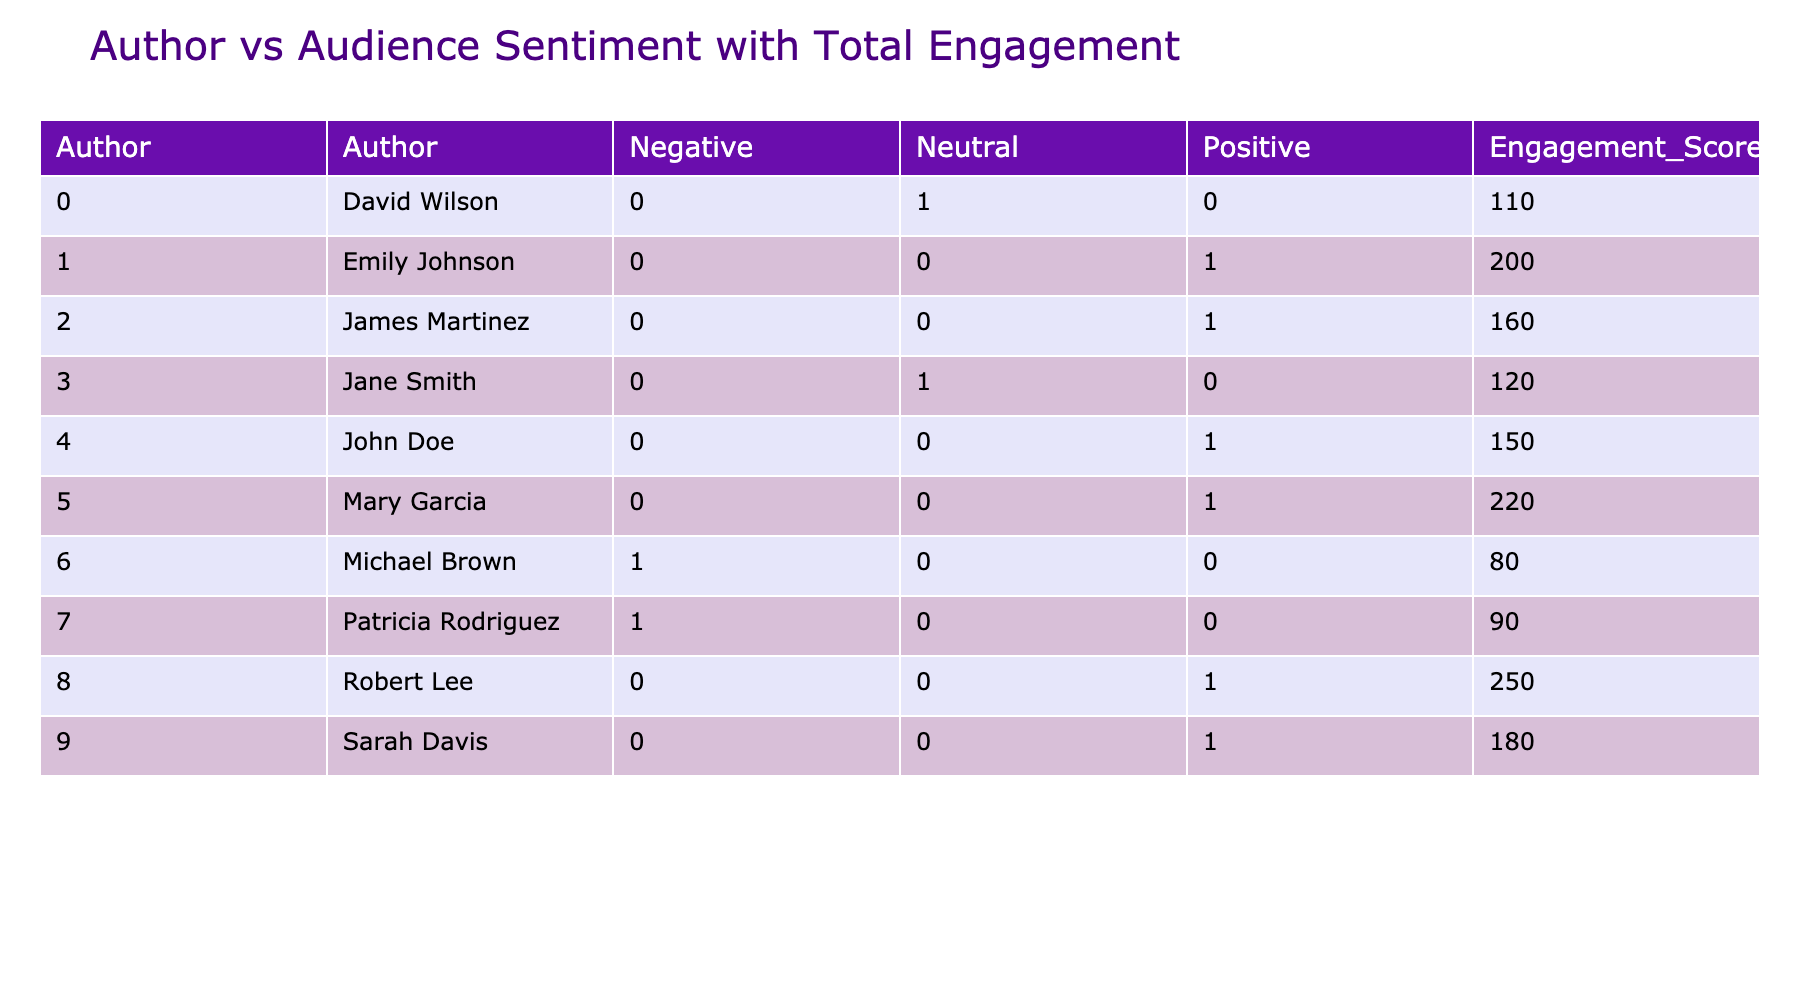What is the total engagement score for Sarah Davis? According to the table, we look under the Engagement Score column for Sarah Davis. The figure for Sarah Davis is 180.
Answer: 180 Which author received the most positive audience sentiment? By examining the Audience Sentiment column, we notice that multiple posts have a positive sentiment. However, the Post with the highest engagement score belongs to Robert Lee with an Engagement Score of 250.
Answer: Robert Lee Is there any author whose posts have only neutral or negative audience sentiment? Upon checking the Audience Sentiment column for each author, we find that Jane Smith and David Wilson have only neutral sentiments and Michael Brown and Patricia Rodriguez only negative sentiments across their posts. Therefore, the answer is yes as Jane Smith authors neutral posts.
Answer: Yes What is the average engagement score for posts with negative audience sentiment? To calculate the average, we need to identify the engagement scores of posts with negative sentiment from the table. The relevant posts are by Michael Brown (80) and Patricia Rodriguez (90). The average score is (80 + 90) / 2 = 85.
Answer: 85 How many posts by Emily Johnson received positive sentiment? In the Audience Sentiment column, Emily Johnson has only one post with positive sentiment titled "How Secular Humanism Empowers Individuals," confirming that there is just one positive post by her.
Answer: 1 What is the total number of posts that have a neutral sentiment? To determine this, we count the number of authors with posts classified as neutral in the Audience Sentiment column. There are two neutral posts: one by Jane Smith and one by David Wilson, leading to a total of two.
Answer: 2 Which author has the highest average engagement score based on their posts? To find the average engagement score for each author, we sum up their engagement scores and divide by the number of their posts. Robert Lee has one post with 250, while Mary Garcia has one with 220. The highest average, therefore, belongs to Robert Lee at 250.
Answer: Robert Lee Is there an author whose engagement score is below 100? By reviewing the Engagement Score column, we see that Michael Brown has a score of 80 and Patricia Rodriguez has a score of 90. Therefore, there is an author with scores below 100, which confirms the answer.
Answer: Yes 